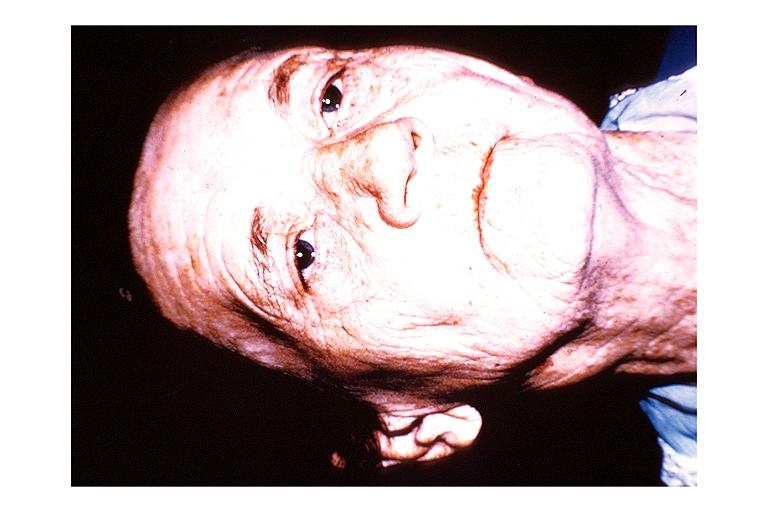where is this?
Answer the question using a single word or phrase. Oral 